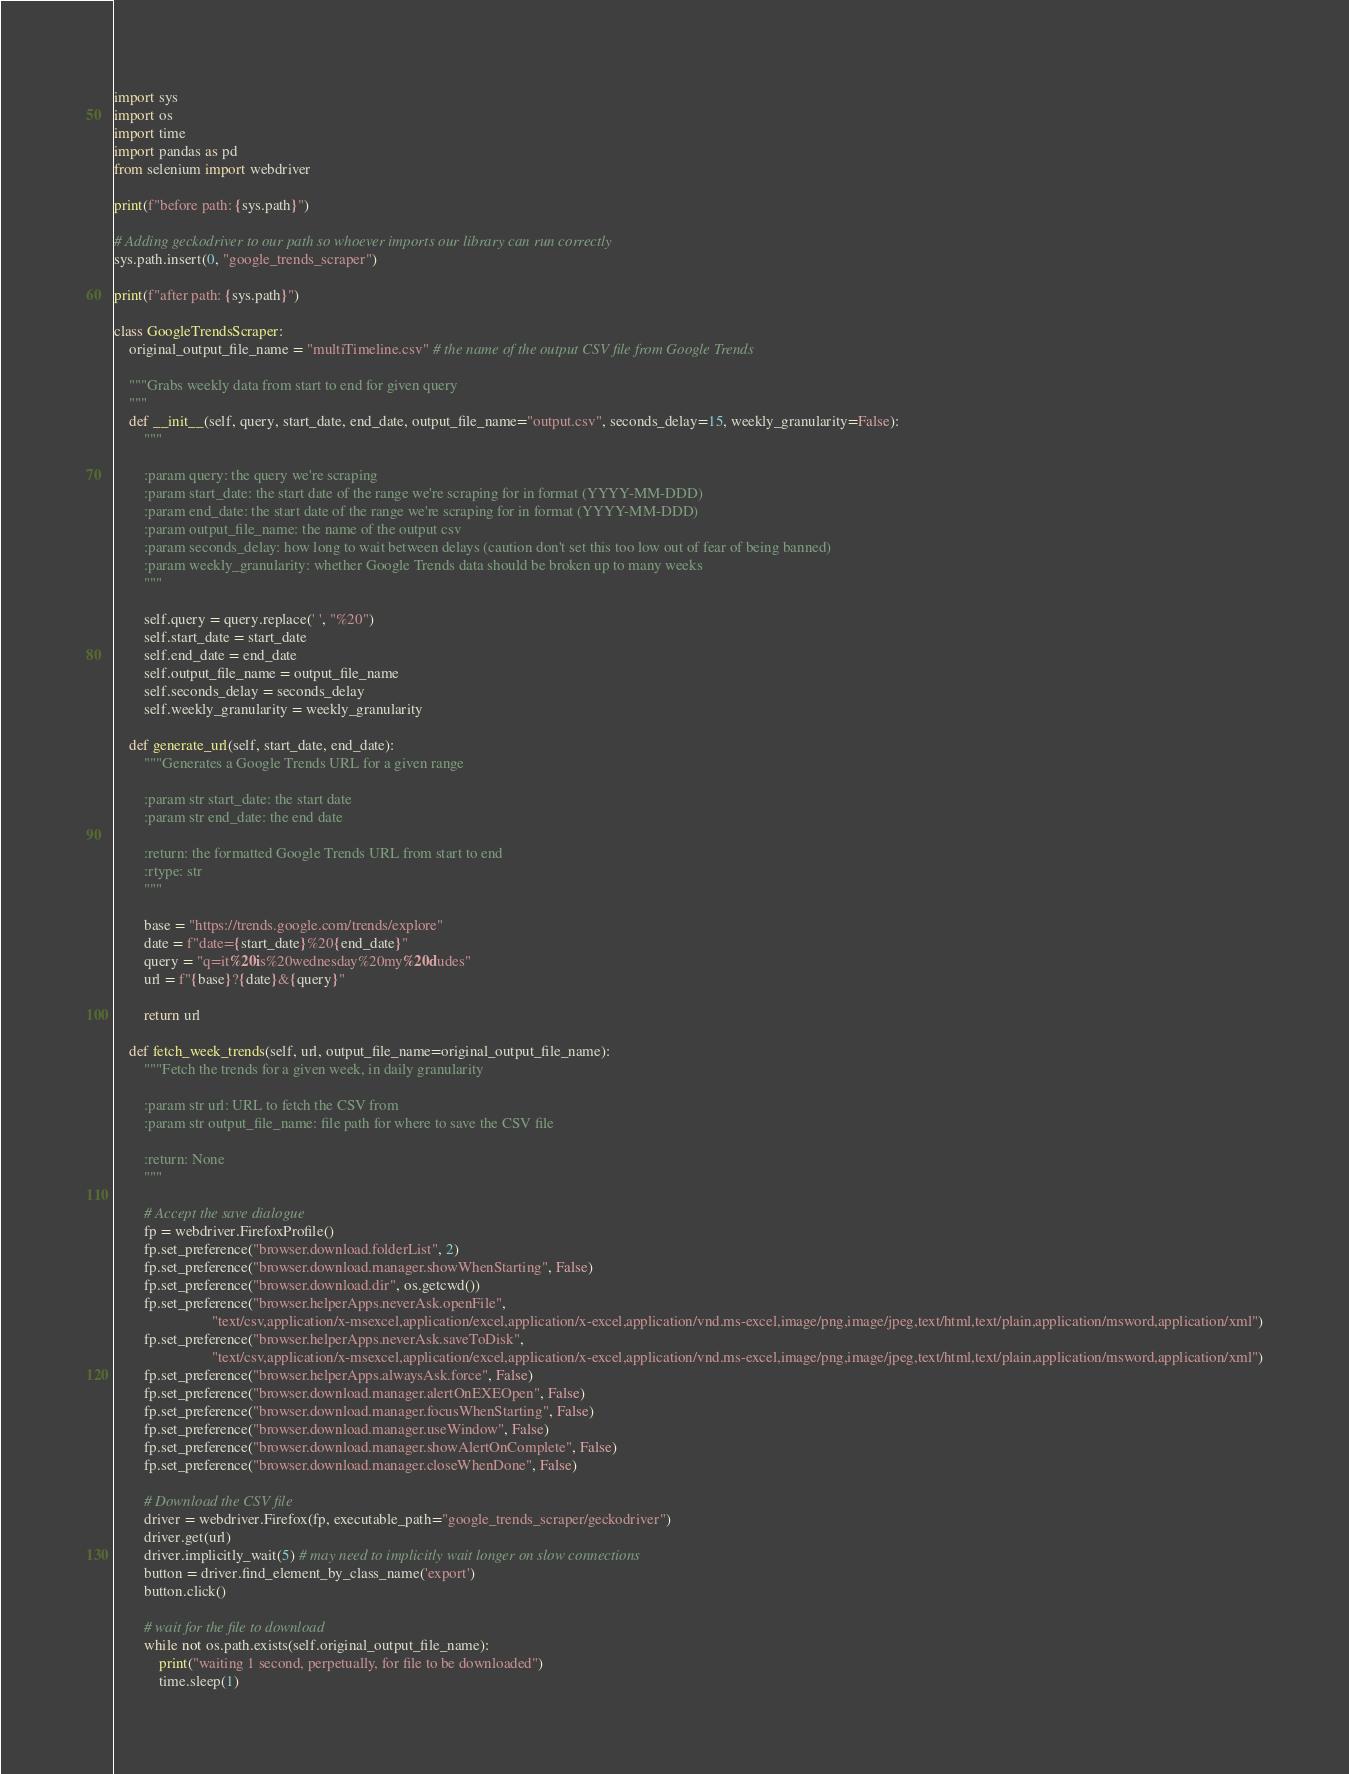<code> <loc_0><loc_0><loc_500><loc_500><_Python_>import sys
import os
import time
import pandas as pd
from selenium import webdriver

print(f"before path: {sys.path}")

# Adding geckodriver to our path so whoever imports our library can run correctly
sys.path.insert(0, "google_trends_scraper")

print(f"after path: {sys.path}")

class GoogleTrendsScraper:
    original_output_file_name = "multiTimeline.csv" # the name of the output CSV file from Google Trends

    """Grabs weekly data from start to end for given query
    """
    def __init__(self, query, start_date, end_date, output_file_name="output.csv", seconds_delay=15, weekly_granularity=False):
        """

        :param query: the query we're scraping
        :param start_date: the start date of the range we're scraping for in format (YYYY-MM-DDD)
        :param end_date: the start date of the range we're scraping for in format (YYYY-MM-DDD)
        :param output_file_name: the name of the output csv
        :param seconds_delay: how long to wait between delays (caution don't set this too low out of fear of being banned)
        :param weekly_granularity: whether Google Trends data should be broken up to many weeks
        """

        self.query = query.replace(' ', "%20")
        self.start_date = start_date
        self.end_date = end_date
        self.output_file_name = output_file_name
        self.seconds_delay = seconds_delay
        self.weekly_granularity = weekly_granularity

    def generate_url(self, start_date, end_date):
        """Generates a Google Trends URL for a given range

        :param str start_date: the start date
        :param str end_date: the end date

        :return: the formatted Google Trends URL from start to end
        :rtype: str
        """

        base = "https://trends.google.com/trends/explore"
        date = f"date={start_date}%20{end_date}"
        query = "q=it%20is%20wednesday%20my%20dudes"
        url = f"{base}?{date}&{query}"

        return url

    def fetch_week_trends(self, url, output_file_name=original_output_file_name):
        """Fetch the trends for a given week, in daily granularity

        :param str url: URL to fetch the CSV from
        :param str output_file_name: file path for where to save the CSV file

        :return: None
        """

        # Accept the save dialogue
        fp = webdriver.FirefoxProfile()
        fp.set_preference("browser.download.folderList", 2)
        fp.set_preference("browser.download.manager.showWhenStarting", False)
        fp.set_preference("browser.download.dir", os.getcwd())
        fp.set_preference("browser.helperApps.neverAsk.openFile",
                          "text/csv,application/x-msexcel,application/excel,application/x-excel,application/vnd.ms-excel,image/png,image/jpeg,text/html,text/plain,application/msword,application/xml")
        fp.set_preference("browser.helperApps.neverAsk.saveToDisk",
                          "text/csv,application/x-msexcel,application/excel,application/x-excel,application/vnd.ms-excel,image/png,image/jpeg,text/html,text/plain,application/msword,application/xml")
        fp.set_preference("browser.helperApps.alwaysAsk.force", False)
        fp.set_preference("browser.download.manager.alertOnEXEOpen", False)
        fp.set_preference("browser.download.manager.focusWhenStarting", False)
        fp.set_preference("browser.download.manager.useWindow", False)
        fp.set_preference("browser.download.manager.showAlertOnComplete", False)
        fp.set_preference("browser.download.manager.closeWhenDone", False)

        # Download the CSV file
        driver = webdriver.Firefox(fp, executable_path="google_trends_scraper/geckodriver")
        driver.get(url)
        driver.implicitly_wait(5) # may need to implicitly wait longer on slow connections
        button = driver.find_element_by_class_name('export')
        button.click()

        # wait for the file to download
        while not os.path.exists(self.original_output_file_name):
            print("waiting 1 second, perpetually, for file to be downloaded")
            time.sleep(1)
</code> 